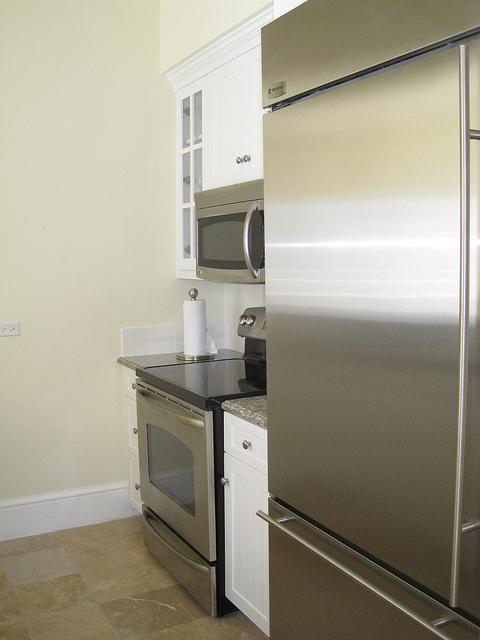How many bunches of bananas are pictured?
Give a very brief answer. 0. 